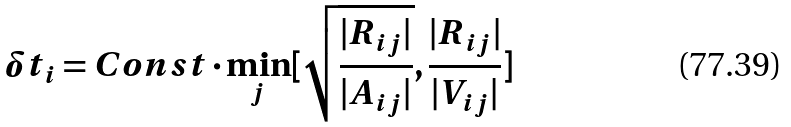Convert formula to latex. <formula><loc_0><loc_0><loc_500><loc_500>\delta t _ { i } = C o n s t \cdot \min _ { j } [ \sqrt { \frac { | { R } _ { i j } | } { | { A } _ { i j } | } } , \frac { | { R } _ { i j } | } { | { V } _ { i j } | } ]</formula> 